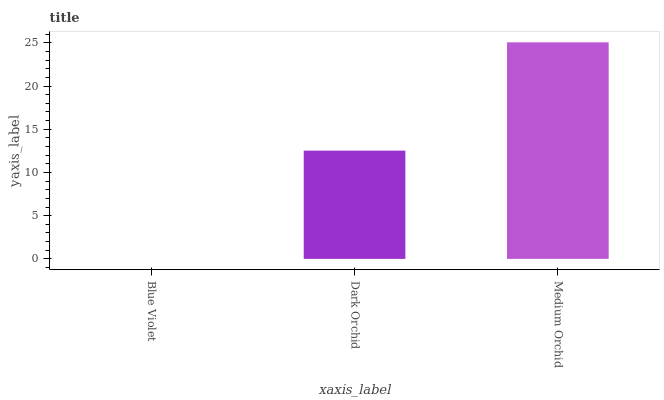Is Blue Violet the minimum?
Answer yes or no. Yes. Is Medium Orchid the maximum?
Answer yes or no. Yes. Is Dark Orchid the minimum?
Answer yes or no. No. Is Dark Orchid the maximum?
Answer yes or no. No. Is Dark Orchid greater than Blue Violet?
Answer yes or no. Yes. Is Blue Violet less than Dark Orchid?
Answer yes or no. Yes. Is Blue Violet greater than Dark Orchid?
Answer yes or no. No. Is Dark Orchid less than Blue Violet?
Answer yes or no. No. Is Dark Orchid the high median?
Answer yes or no. Yes. Is Dark Orchid the low median?
Answer yes or no. Yes. Is Blue Violet the high median?
Answer yes or no. No. Is Medium Orchid the low median?
Answer yes or no. No. 